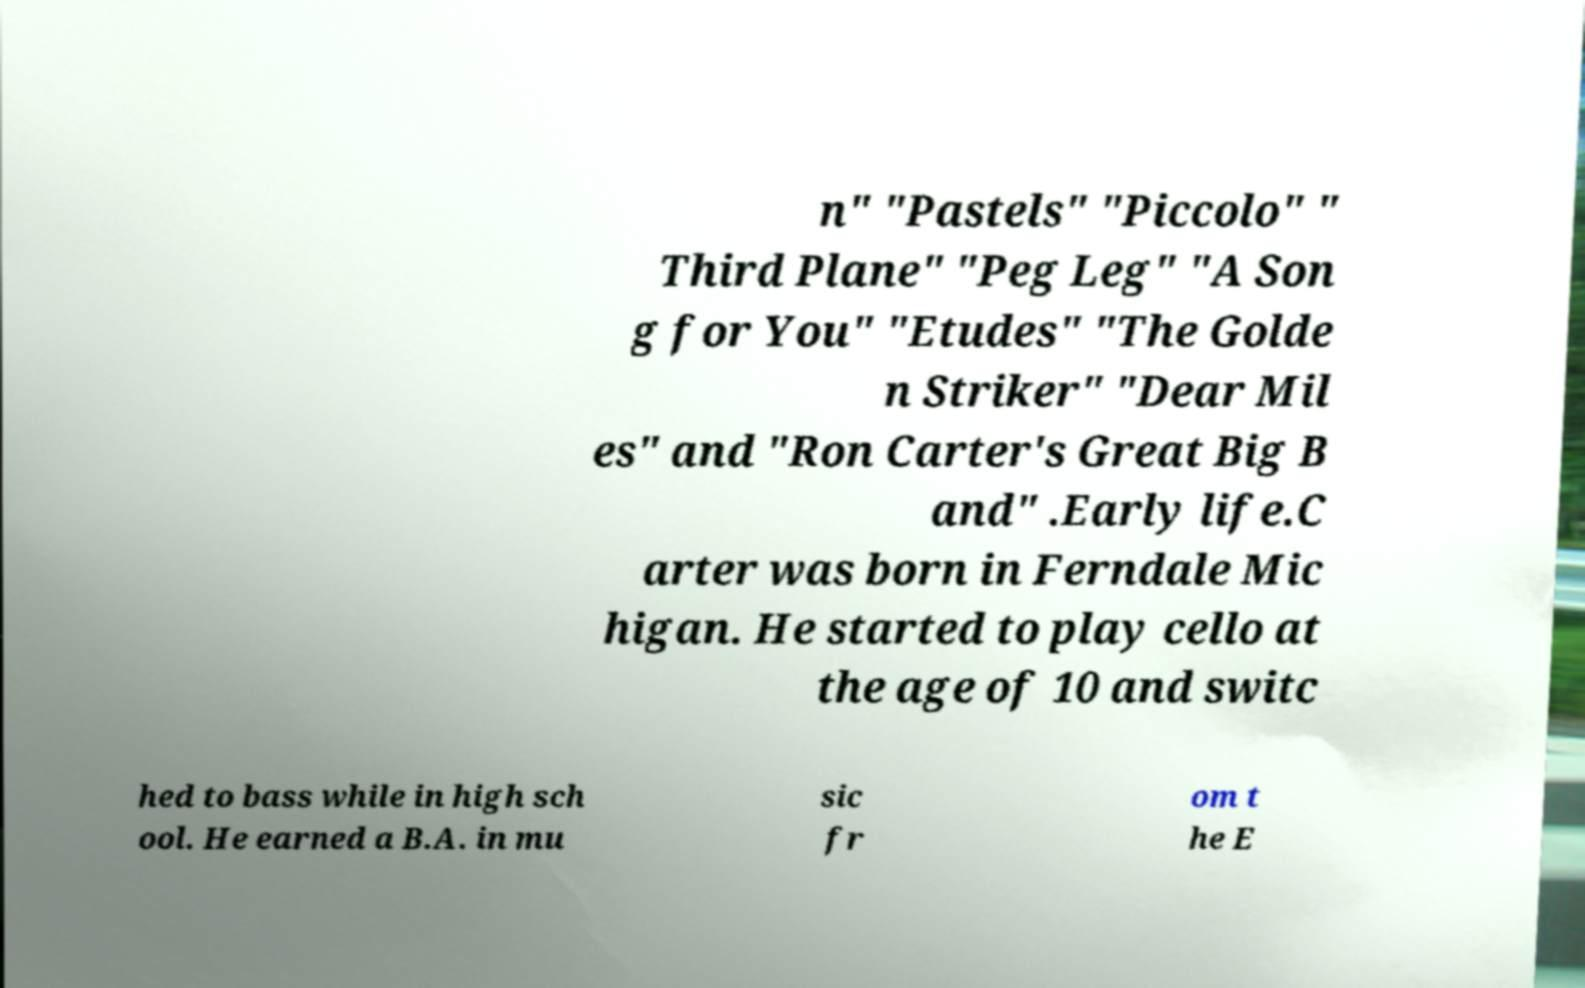Could you assist in decoding the text presented in this image and type it out clearly? n" "Pastels" "Piccolo" " Third Plane" "Peg Leg" "A Son g for You" "Etudes" "The Golde n Striker" "Dear Mil es" and "Ron Carter's Great Big B and" .Early life.C arter was born in Ferndale Mic higan. He started to play cello at the age of 10 and switc hed to bass while in high sch ool. He earned a B.A. in mu sic fr om t he E 